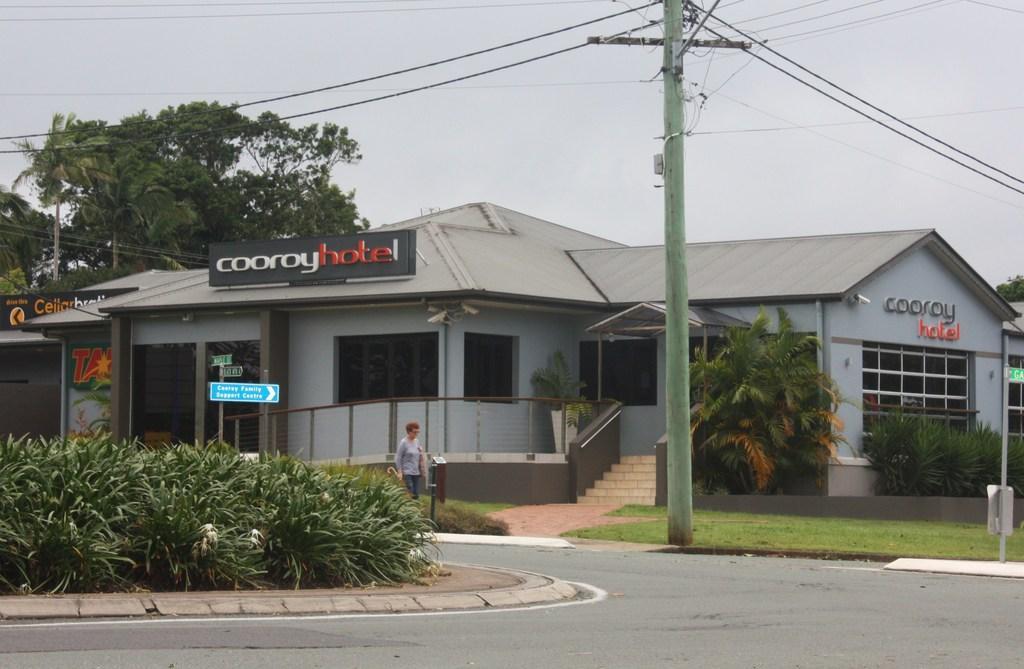How would you summarize this image in a sentence or two? This image is taken outdoors. At the top of the image there is the sky. At the bottom of the image there is a road. In the background there are a few trees. In the middle of the image there are a few houses with walls, windows, doors and roofs. There are a few boards with text on them. There are a few stairs. There is a fence and there is a railing. There are a few trees and plants on the ground and there is a ground with grass on it. There is a pole with many wires. A woman is walking on the road and she is holding an object in her hand. 